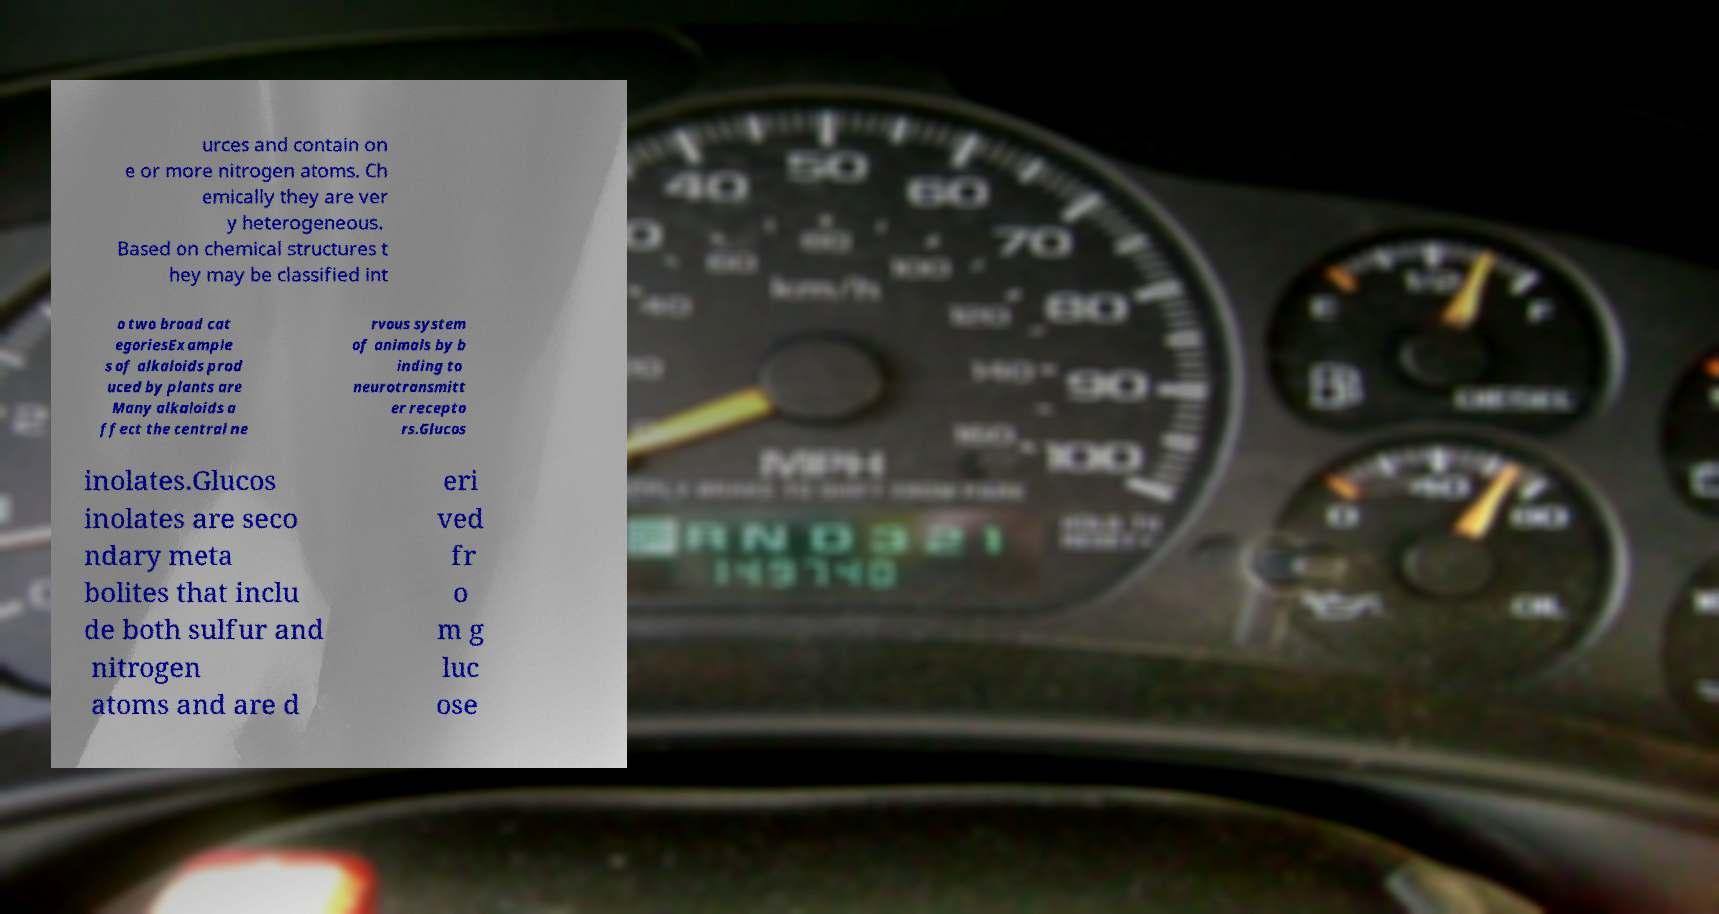Please read and relay the text visible in this image. What does it say? urces and contain on e or more nitrogen atoms. Ch emically they are ver y heterogeneous. Based on chemical structures t hey may be classified int o two broad cat egoriesExample s of alkaloids prod uced by plants are Many alkaloids a ffect the central ne rvous system of animals by b inding to neurotransmitt er recepto rs.Glucos inolates.Glucos inolates are seco ndary meta bolites that inclu de both sulfur and nitrogen atoms and are d eri ved fr o m g luc ose 